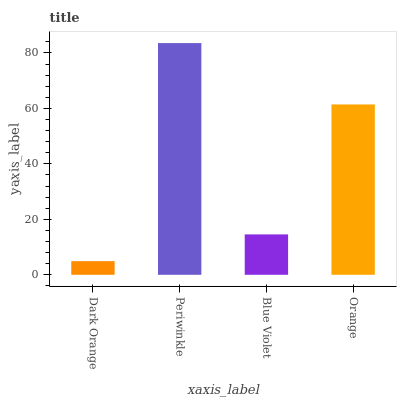Is Dark Orange the minimum?
Answer yes or no. Yes. Is Periwinkle the maximum?
Answer yes or no. Yes. Is Blue Violet the minimum?
Answer yes or no. No. Is Blue Violet the maximum?
Answer yes or no. No. Is Periwinkle greater than Blue Violet?
Answer yes or no. Yes. Is Blue Violet less than Periwinkle?
Answer yes or no. Yes. Is Blue Violet greater than Periwinkle?
Answer yes or no. No. Is Periwinkle less than Blue Violet?
Answer yes or no. No. Is Orange the high median?
Answer yes or no. Yes. Is Blue Violet the low median?
Answer yes or no. Yes. Is Dark Orange the high median?
Answer yes or no. No. Is Orange the low median?
Answer yes or no. No. 